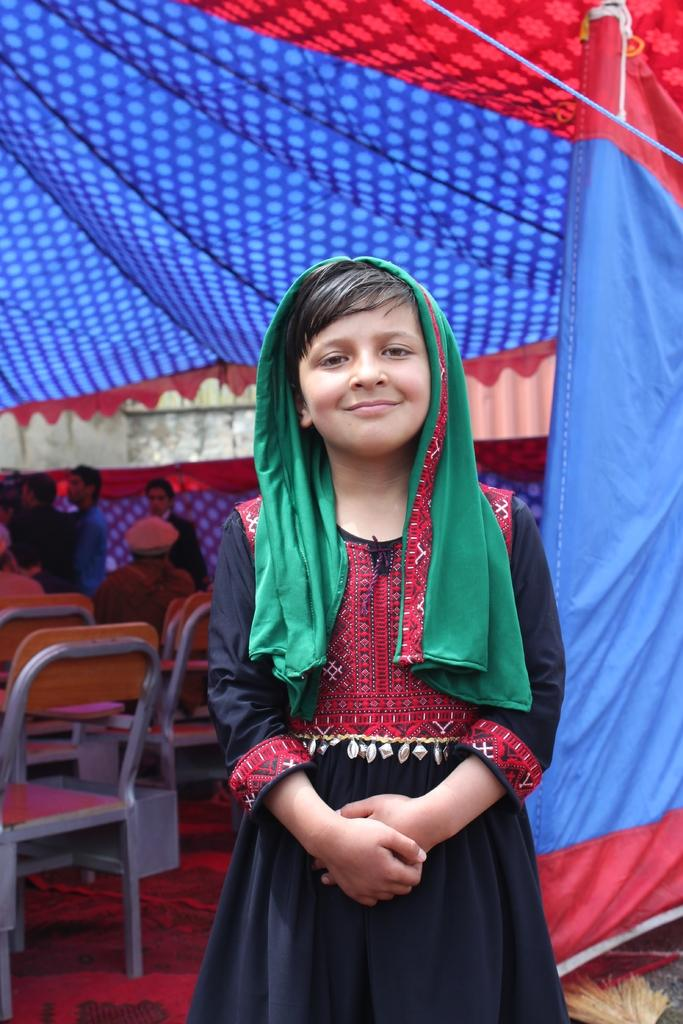What is the girl in the image wearing? The girl is wearing a black dress in the image. What is the girl doing in the image? The girl is standing and smiling in the image. Can you describe the group of people in the image? The group of people in the image are sitting and standing under a tent. What is at the bottom of the image? There is a red carpet at the bottom of the image. What type of lip balm is the girl applying in the image? There is no lip balm or any indication of the girl applying anything in the image. 